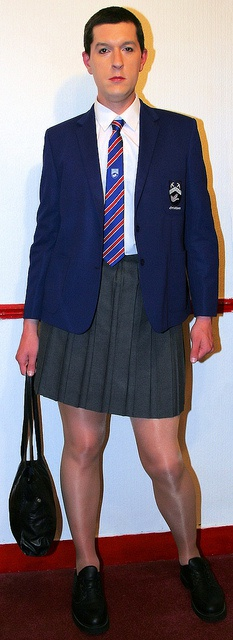Describe the objects in this image and their specific colors. I can see people in ivory, navy, black, and brown tones, handbag in ivory, black, maroon, lightblue, and gray tones, and tie in ivory, darkblue, blue, lightgray, and brown tones in this image. 